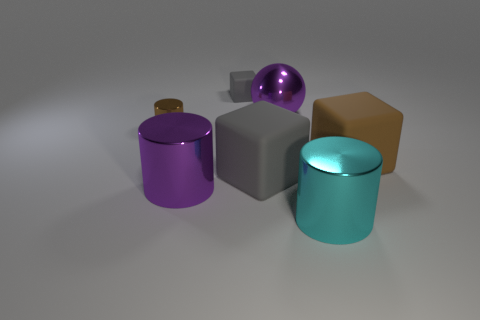Add 2 tiny brown metal objects. How many objects exist? 9 Subtract all balls. How many objects are left? 6 Add 3 tiny green rubber objects. How many tiny green rubber objects exist? 3 Subtract 0 red spheres. How many objects are left? 7 Subtract all big cyan objects. Subtract all small brown shiny cylinders. How many objects are left? 5 Add 5 big shiny cylinders. How many big shiny cylinders are left? 7 